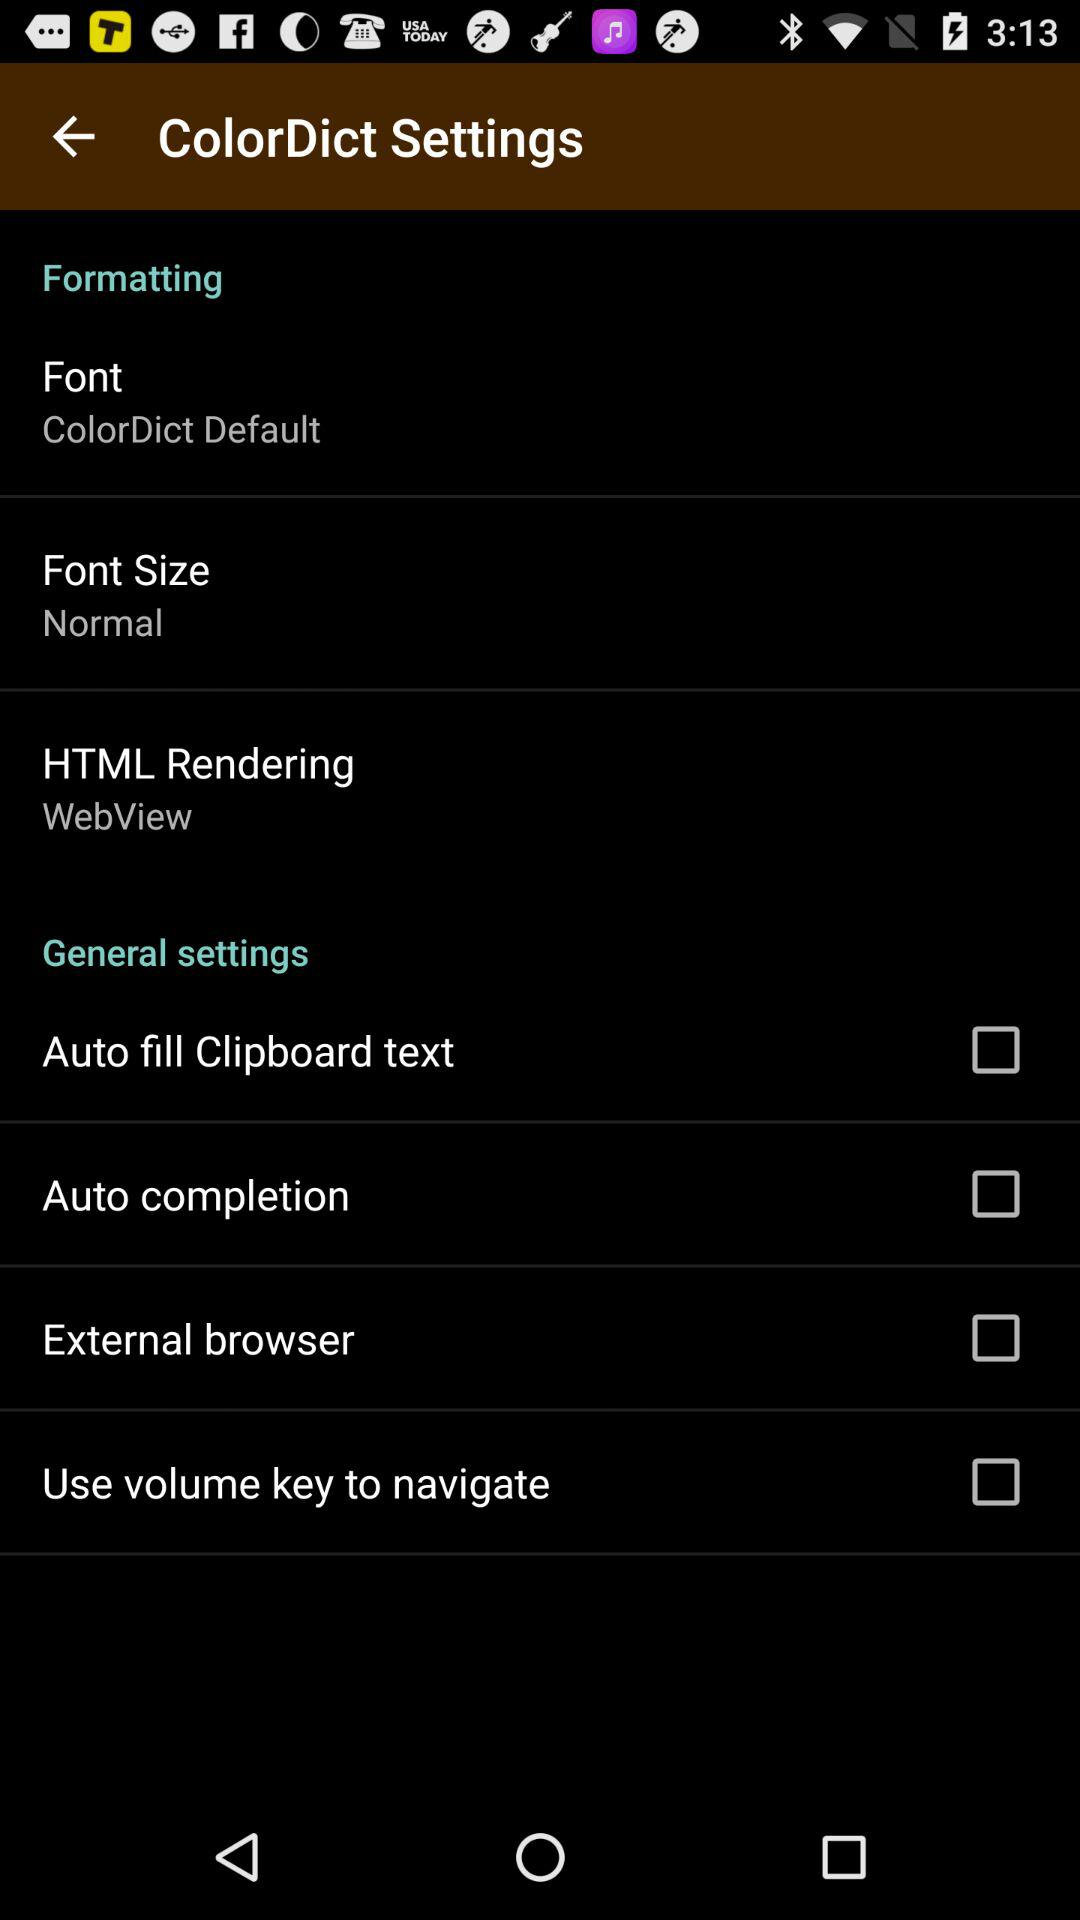What is the status of "Use volume key to navigate"? The status is "off". 